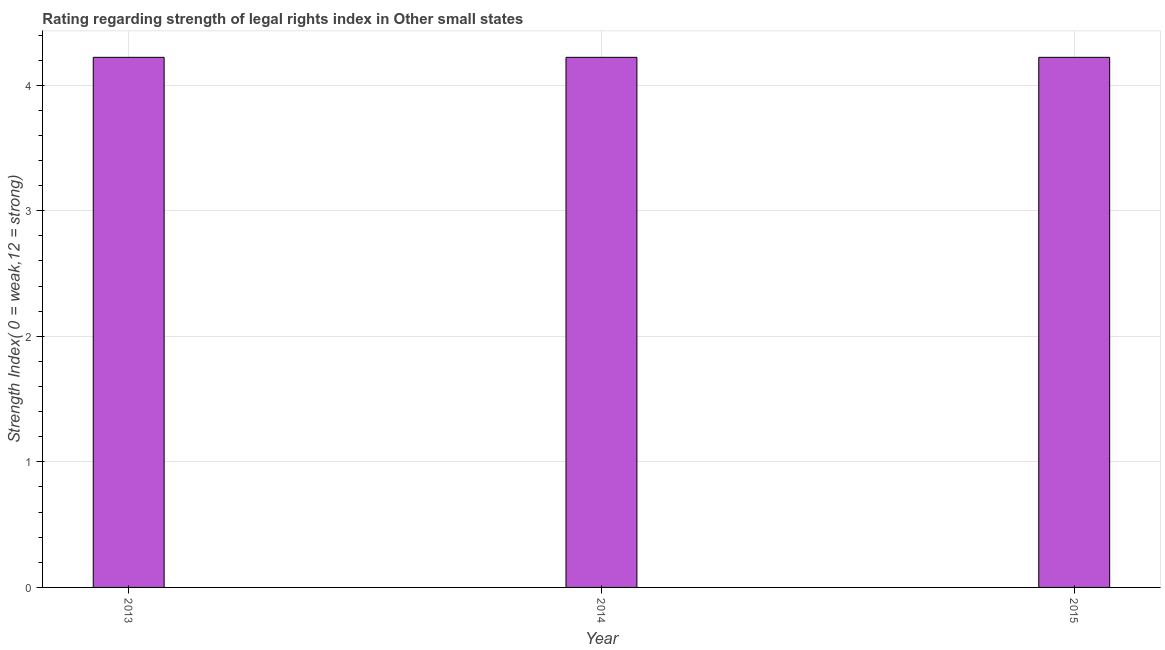Does the graph contain any zero values?
Offer a terse response. No. Does the graph contain grids?
Ensure brevity in your answer.  Yes. What is the title of the graph?
Provide a succinct answer. Rating regarding strength of legal rights index in Other small states. What is the label or title of the X-axis?
Offer a very short reply. Year. What is the label or title of the Y-axis?
Provide a short and direct response. Strength Index( 0 = weak,12 = strong). What is the strength of legal rights index in 2013?
Your answer should be very brief. 4.22. Across all years, what is the maximum strength of legal rights index?
Your answer should be very brief. 4.22. Across all years, what is the minimum strength of legal rights index?
Your answer should be compact. 4.22. In which year was the strength of legal rights index maximum?
Give a very brief answer. 2013. What is the sum of the strength of legal rights index?
Provide a succinct answer. 12.67. What is the average strength of legal rights index per year?
Offer a very short reply. 4.22. What is the median strength of legal rights index?
Provide a short and direct response. 4.22. What is the ratio of the strength of legal rights index in 2013 to that in 2014?
Keep it short and to the point. 1. Is the strength of legal rights index in 2013 less than that in 2015?
Your response must be concise. No. Is the difference between the strength of legal rights index in 2013 and 2015 greater than the difference between any two years?
Offer a very short reply. Yes. In how many years, is the strength of legal rights index greater than the average strength of legal rights index taken over all years?
Provide a succinct answer. 0. How many bars are there?
Ensure brevity in your answer.  3. What is the difference between two consecutive major ticks on the Y-axis?
Provide a succinct answer. 1. What is the Strength Index( 0 = weak,12 = strong) in 2013?
Offer a very short reply. 4.22. What is the Strength Index( 0 = weak,12 = strong) of 2014?
Offer a very short reply. 4.22. What is the Strength Index( 0 = weak,12 = strong) in 2015?
Keep it short and to the point. 4.22. What is the difference between the Strength Index( 0 = weak,12 = strong) in 2013 and 2015?
Offer a very short reply. 0. What is the difference between the Strength Index( 0 = weak,12 = strong) in 2014 and 2015?
Provide a succinct answer. 0. What is the ratio of the Strength Index( 0 = weak,12 = strong) in 2013 to that in 2014?
Offer a very short reply. 1. What is the ratio of the Strength Index( 0 = weak,12 = strong) in 2013 to that in 2015?
Offer a terse response. 1. What is the ratio of the Strength Index( 0 = weak,12 = strong) in 2014 to that in 2015?
Make the answer very short. 1. 